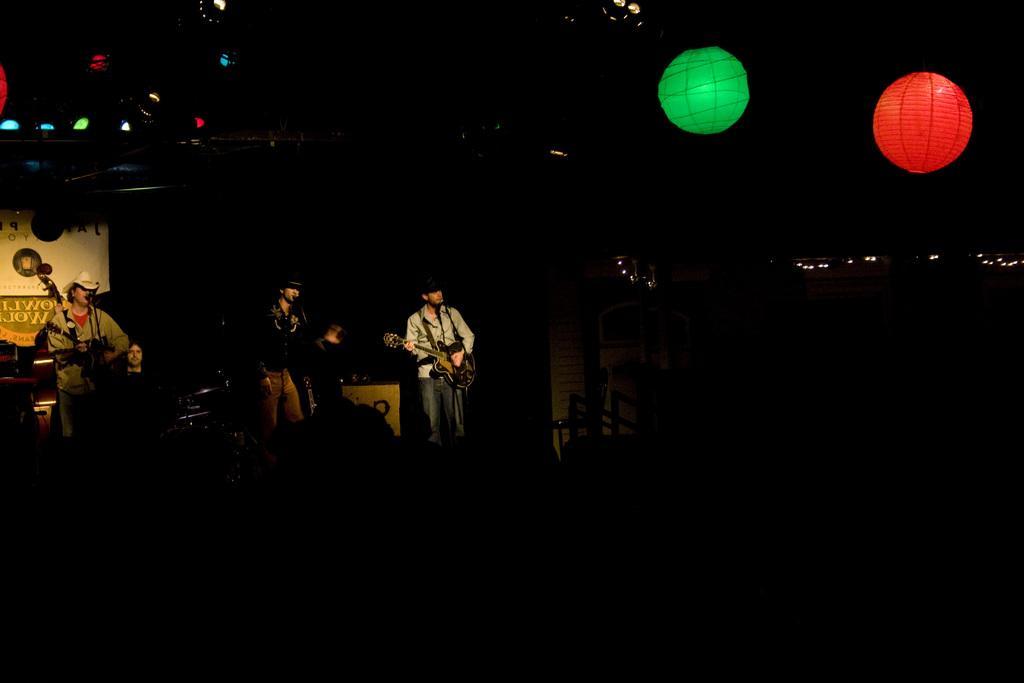Could you give a brief overview of what you see in this image? Here we can see three persons and they are playing guitars. There are decorative balls, lights, and a banner. There is a dark background. 